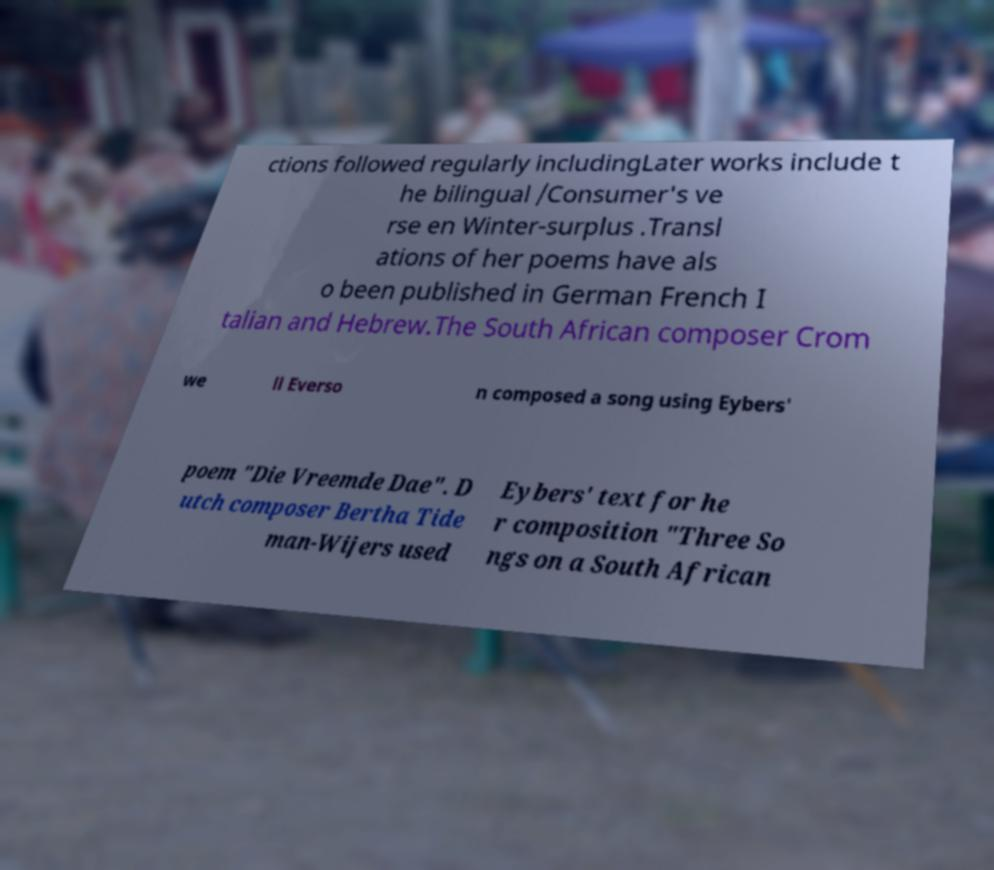I need the written content from this picture converted into text. Can you do that? ctions followed regularly includingLater works include t he bilingual /Consumer's ve rse en Winter-surplus .Transl ations of her poems have als o been published in German French I talian and Hebrew.The South African composer Crom we ll Everso n composed a song using Eybers' poem "Die Vreemde Dae". D utch composer Bertha Tide man-Wijers used Eybers' text for he r composition "Three So ngs on a South African 